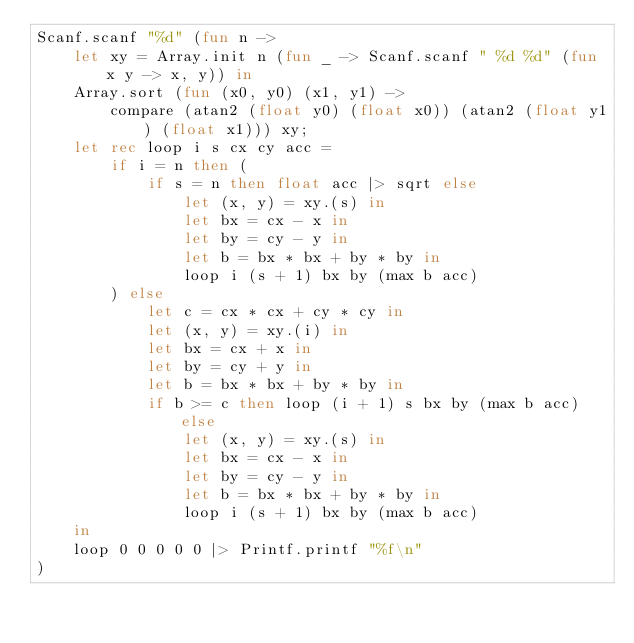Convert code to text. <code><loc_0><loc_0><loc_500><loc_500><_OCaml_>Scanf.scanf "%d" (fun n ->
    let xy = Array.init n (fun _ -> Scanf.scanf " %d %d" (fun x y -> x, y)) in
    Array.sort (fun (x0, y0) (x1, y1) ->
        compare (atan2 (float y0) (float x0)) (atan2 (float y1) (float x1))) xy;
    let rec loop i s cx cy acc =
        if i = n then (
            if s = n then float acc |> sqrt else
                let (x, y) = xy.(s) in
                let bx = cx - x in
                let by = cy - y in
                let b = bx * bx + by * by in
                loop i (s + 1) bx by (max b acc)
        ) else
            let c = cx * cx + cy * cy in
            let (x, y) = xy.(i) in
            let bx = cx + x in
            let by = cy + y in
            let b = bx * bx + by * by in
            if b >= c then loop (i + 1) s bx by (max b acc) else
                let (x, y) = xy.(s) in
                let bx = cx - x in
                let by = cy - y in
                let b = bx * bx + by * by in
                loop i (s + 1) bx by (max b acc)
    in
    loop 0 0 0 0 0 |> Printf.printf "%f\n"
)</code> 